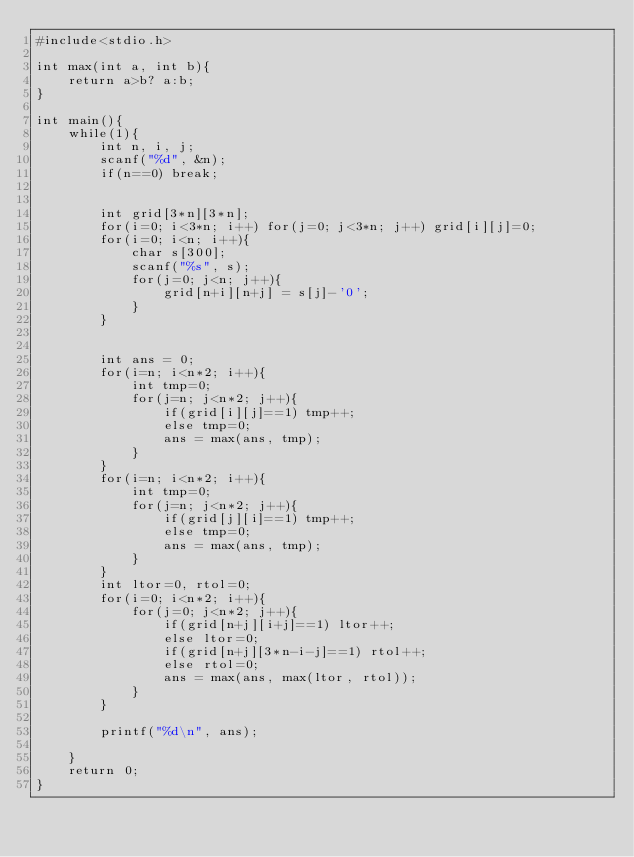Convert code to text. <code><loc_0><loc_0><loc_500><loc_500><_C_>#include<stdio.h>

int max(int a, int b){
	return a>b? a:b;
}

int main(){
	while(1){
		int n, i, j;
		scanf("%d", &n);
		if(n==0) break;

	
		int grid[3*n][3*n];
		for(i=0; i<3*n; i++) for(j=0; j<3*n; j++) grid[i][j]=0;
		for(i=0; i<n; i++){
			char s[300];
			scanf("%s", s);
			for(j=0; j<n; j++){
				grid[n+i][n+j] = s[j]-'0';
			}
		}
		

		int ans = 0;
		for(i=n; i<n*2; i++){
			int tmp=0;
			for(j=n; j<n*2; j++){
				if(grid[i][j]==1) tmp++;
				else tmp=0;
				ans = max(ans, tmp);
			}
		}
		for(i=n; i<n*2; i++){
			int tmp=0;
			for(j=n; j<n*2; j++){
				if(grid[j][i]==1) tmp++;
				else tmp=0;
				ans = max(ans, tmp);
			}
		}
		int ltor=0, rtol=0;
		for(i=0; i<n*2; i++){
			for(j=0; j<n*2; j++){
				if(grid[n+j][i+j]==1) ltor++;
				else ltor=0;
				if(grid[n+j][3*n-i-j]==1) rtol++;
				else rtol=0;
				ans = max(ans, max(ltor, rtol));
			}
		}

		printf("%d\n", ans);

	}
	return 0;
}
</code> 